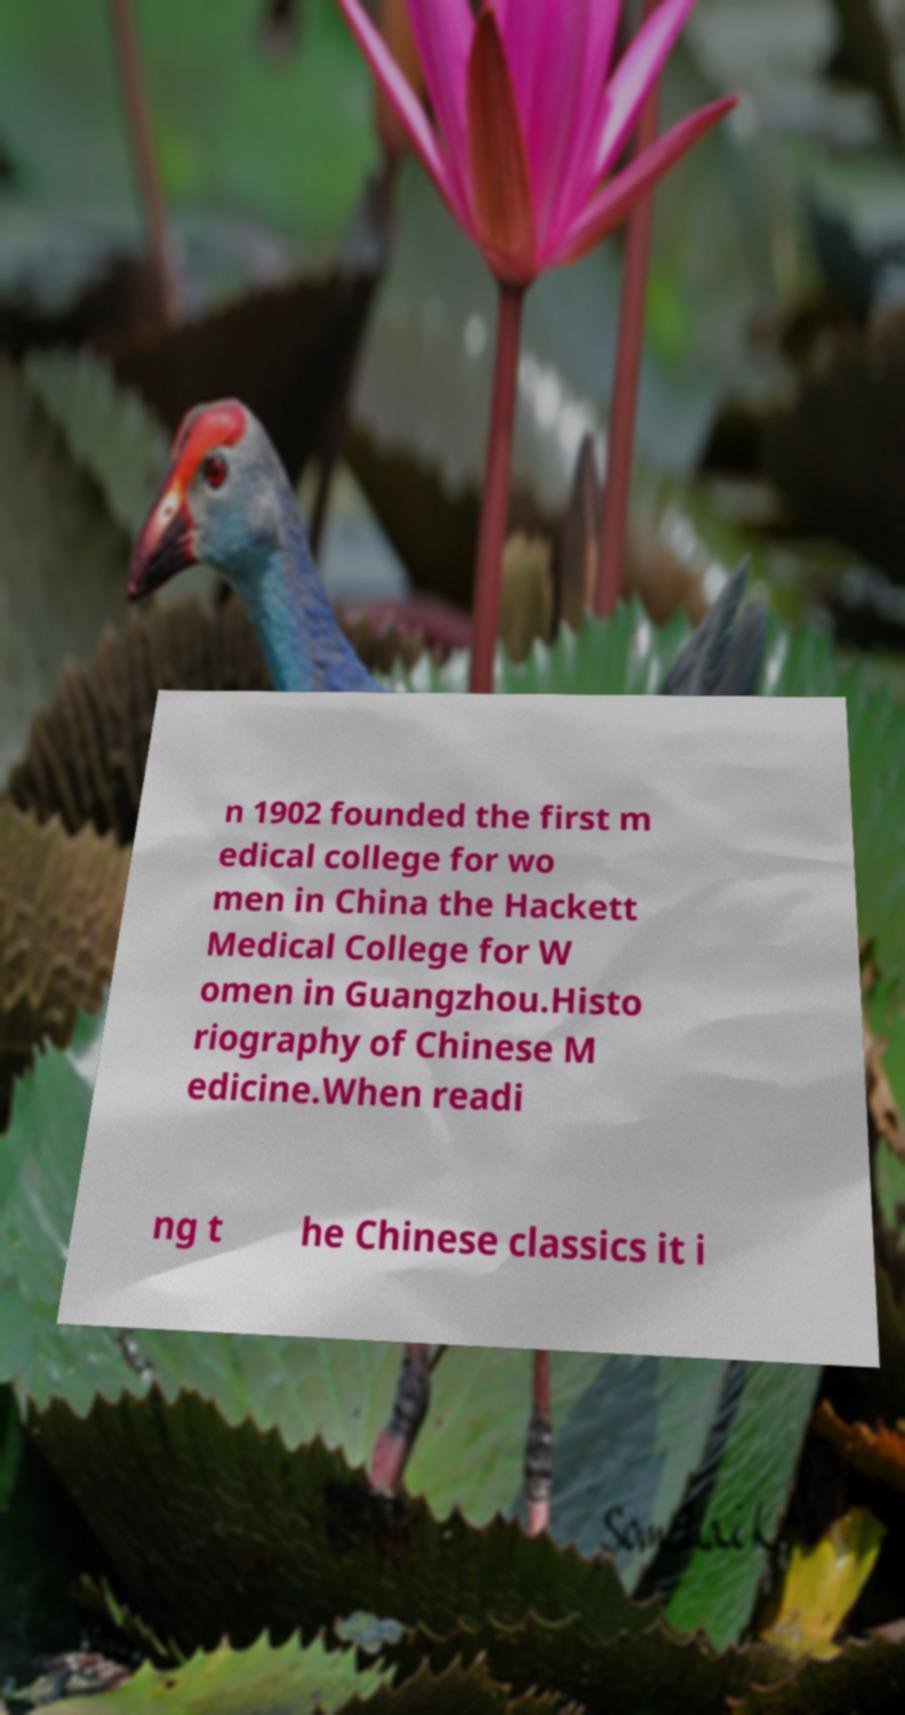Please identify and transcribe the text found in this image. n 1902 founded the first m edical college for wo men in China the Hackett Medical College for W omen in Guangzhou.Histo riography of Chinese M edicine.When readi ng t he Chinese classics it i 